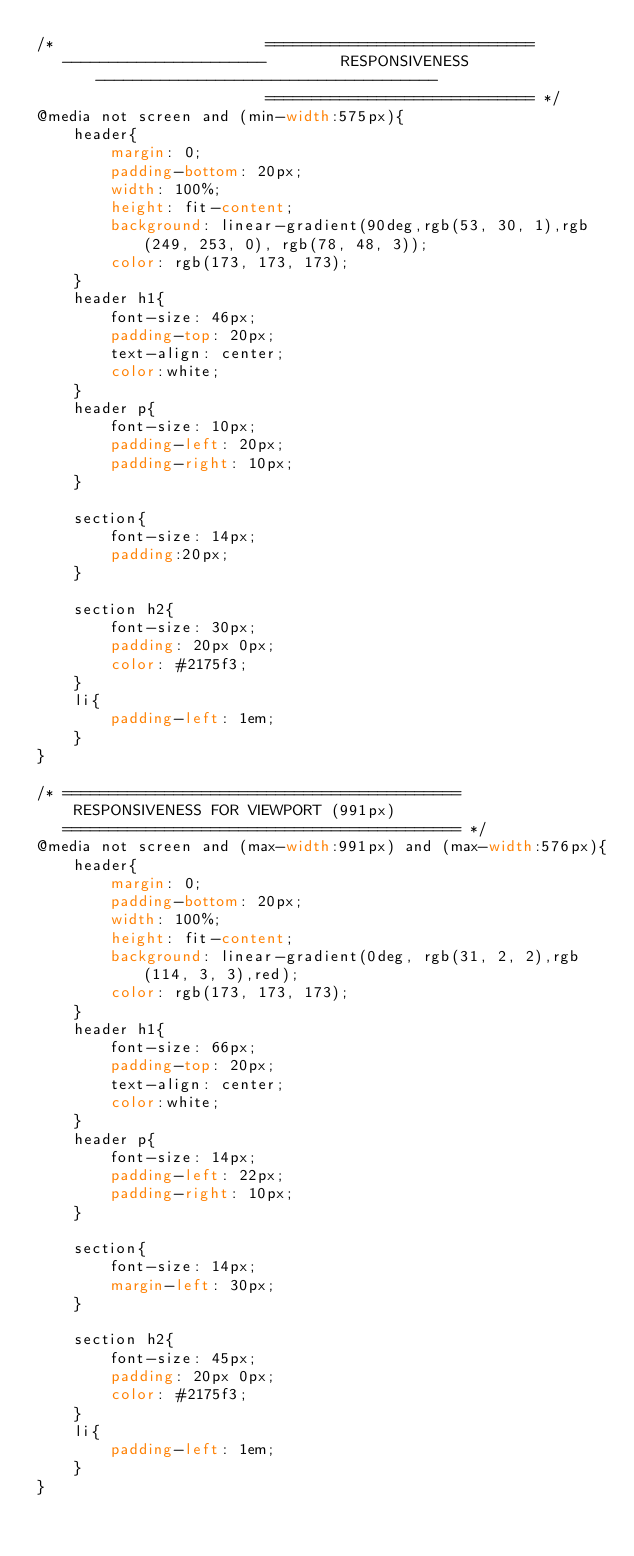Convert code to text. <code><loc_0><loc_0><loc_500><loc_500><_CSS_>/*                       =============================
   ----------------------        RESPONSIVENESS       -------------------------------------
                         ============================= */
@media not screen and (min-width:575px){
    header{
        margin: 0;
        padding-bottom: 20px;
        width: 100%;
        height: fit-content;
        background: linear-gradient(90deg,rgb(53, 30, 1),rgb(249, 253, 0), rgb(78, 48, 3));
        color: rgb(173, 173, 173);
    }
    header h1{
        font-size: 46px;
        padding-top: 20px;
        text-align: center; 
        color:white;
    }
    header p{
        font-size: 10px;
        padding-left: 20px;
        padding-right: 10px;
    }

    section{
        font-size: 14px;
        padding:20px;
    }

    section h2{
        font-size: 30px;
        padding: 20px 0px;
        color: #2175f3;
    }
    li{
        padding-left: 1em;
    }
}

/* ===========================================
    RESPONSIVENESS FOR VIEWPORT (991px)
   =========================================== */
@media not screen and (max-width:991px) and (max-width:576px){
    header{
        margin: 0;
        padding-bottom: 20px;
        width: 100%;
        height: fit-content;
        background: linear-gradient(0deg, rgb(31, 2, 2),rgb(114, 3, 3),red);
        color: rgb(173, 173, 173);
    }
    header h1{
        font-size: 66px;
        padding-top: 20px;
        text-align: center; 
        color:white;
    }
    header p{
        font-size: 14px;
        padding-left: 22px;
        padding-right: 10px;
    }

    section{
        font-size: 14px;
        margin-left: 30px;
    }

    section h2{
        font-size: 45px;
        padding: 20px 0px;
        color: #2175f3;
    }
    li{
        padding-left: 1em;
    }
}
</code> 